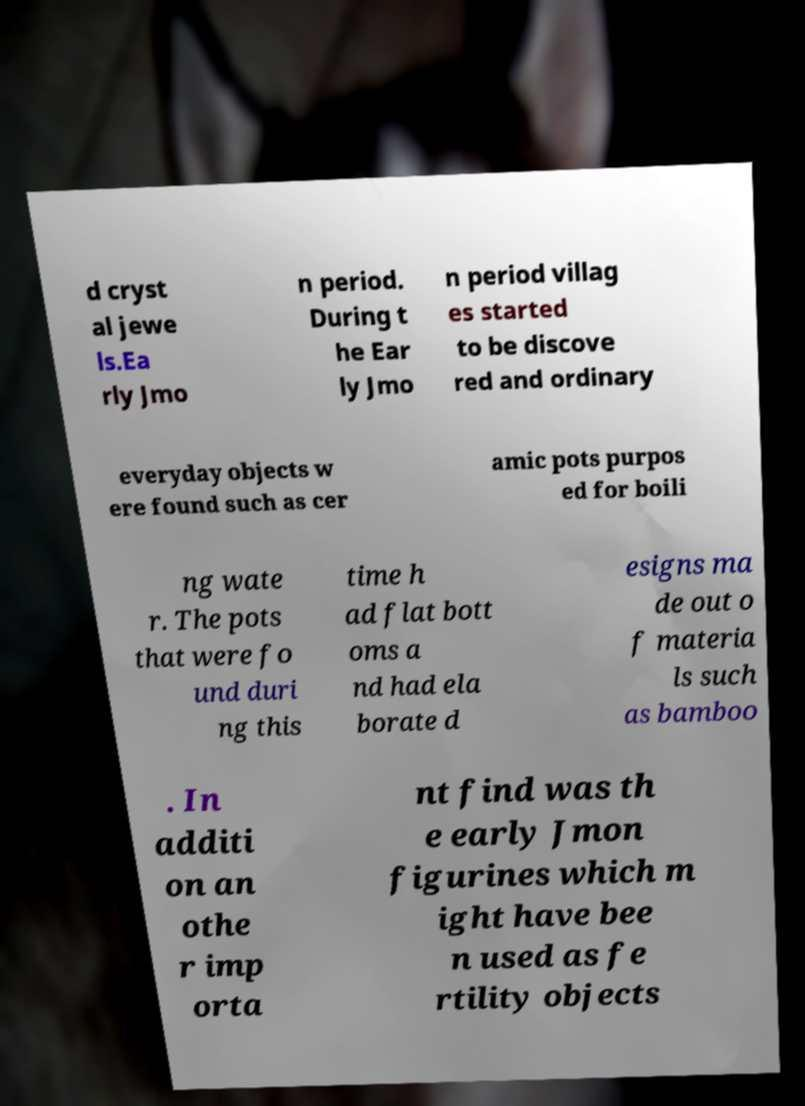Can you read and provide the text displayed in the image?This photo seems to have some interesting text. Can you extract and type it out for me? d cryst al jewe ls.Ea rly Jmo n period. During t he Ear ly Jmo n period villag es started to be discove red and ordinary everyday objects w ere found such as cer amic pots purpos ed for boili ng wate r. The pots that were fo und duri ng this time h ad flat bott oms a nd had ela borate d esigns ma de out o f materia ls such as bamboo . In additi on an othe r imp orta nt find was th e early Jmon figurines which m ight have bee n used as fe rtility objects 